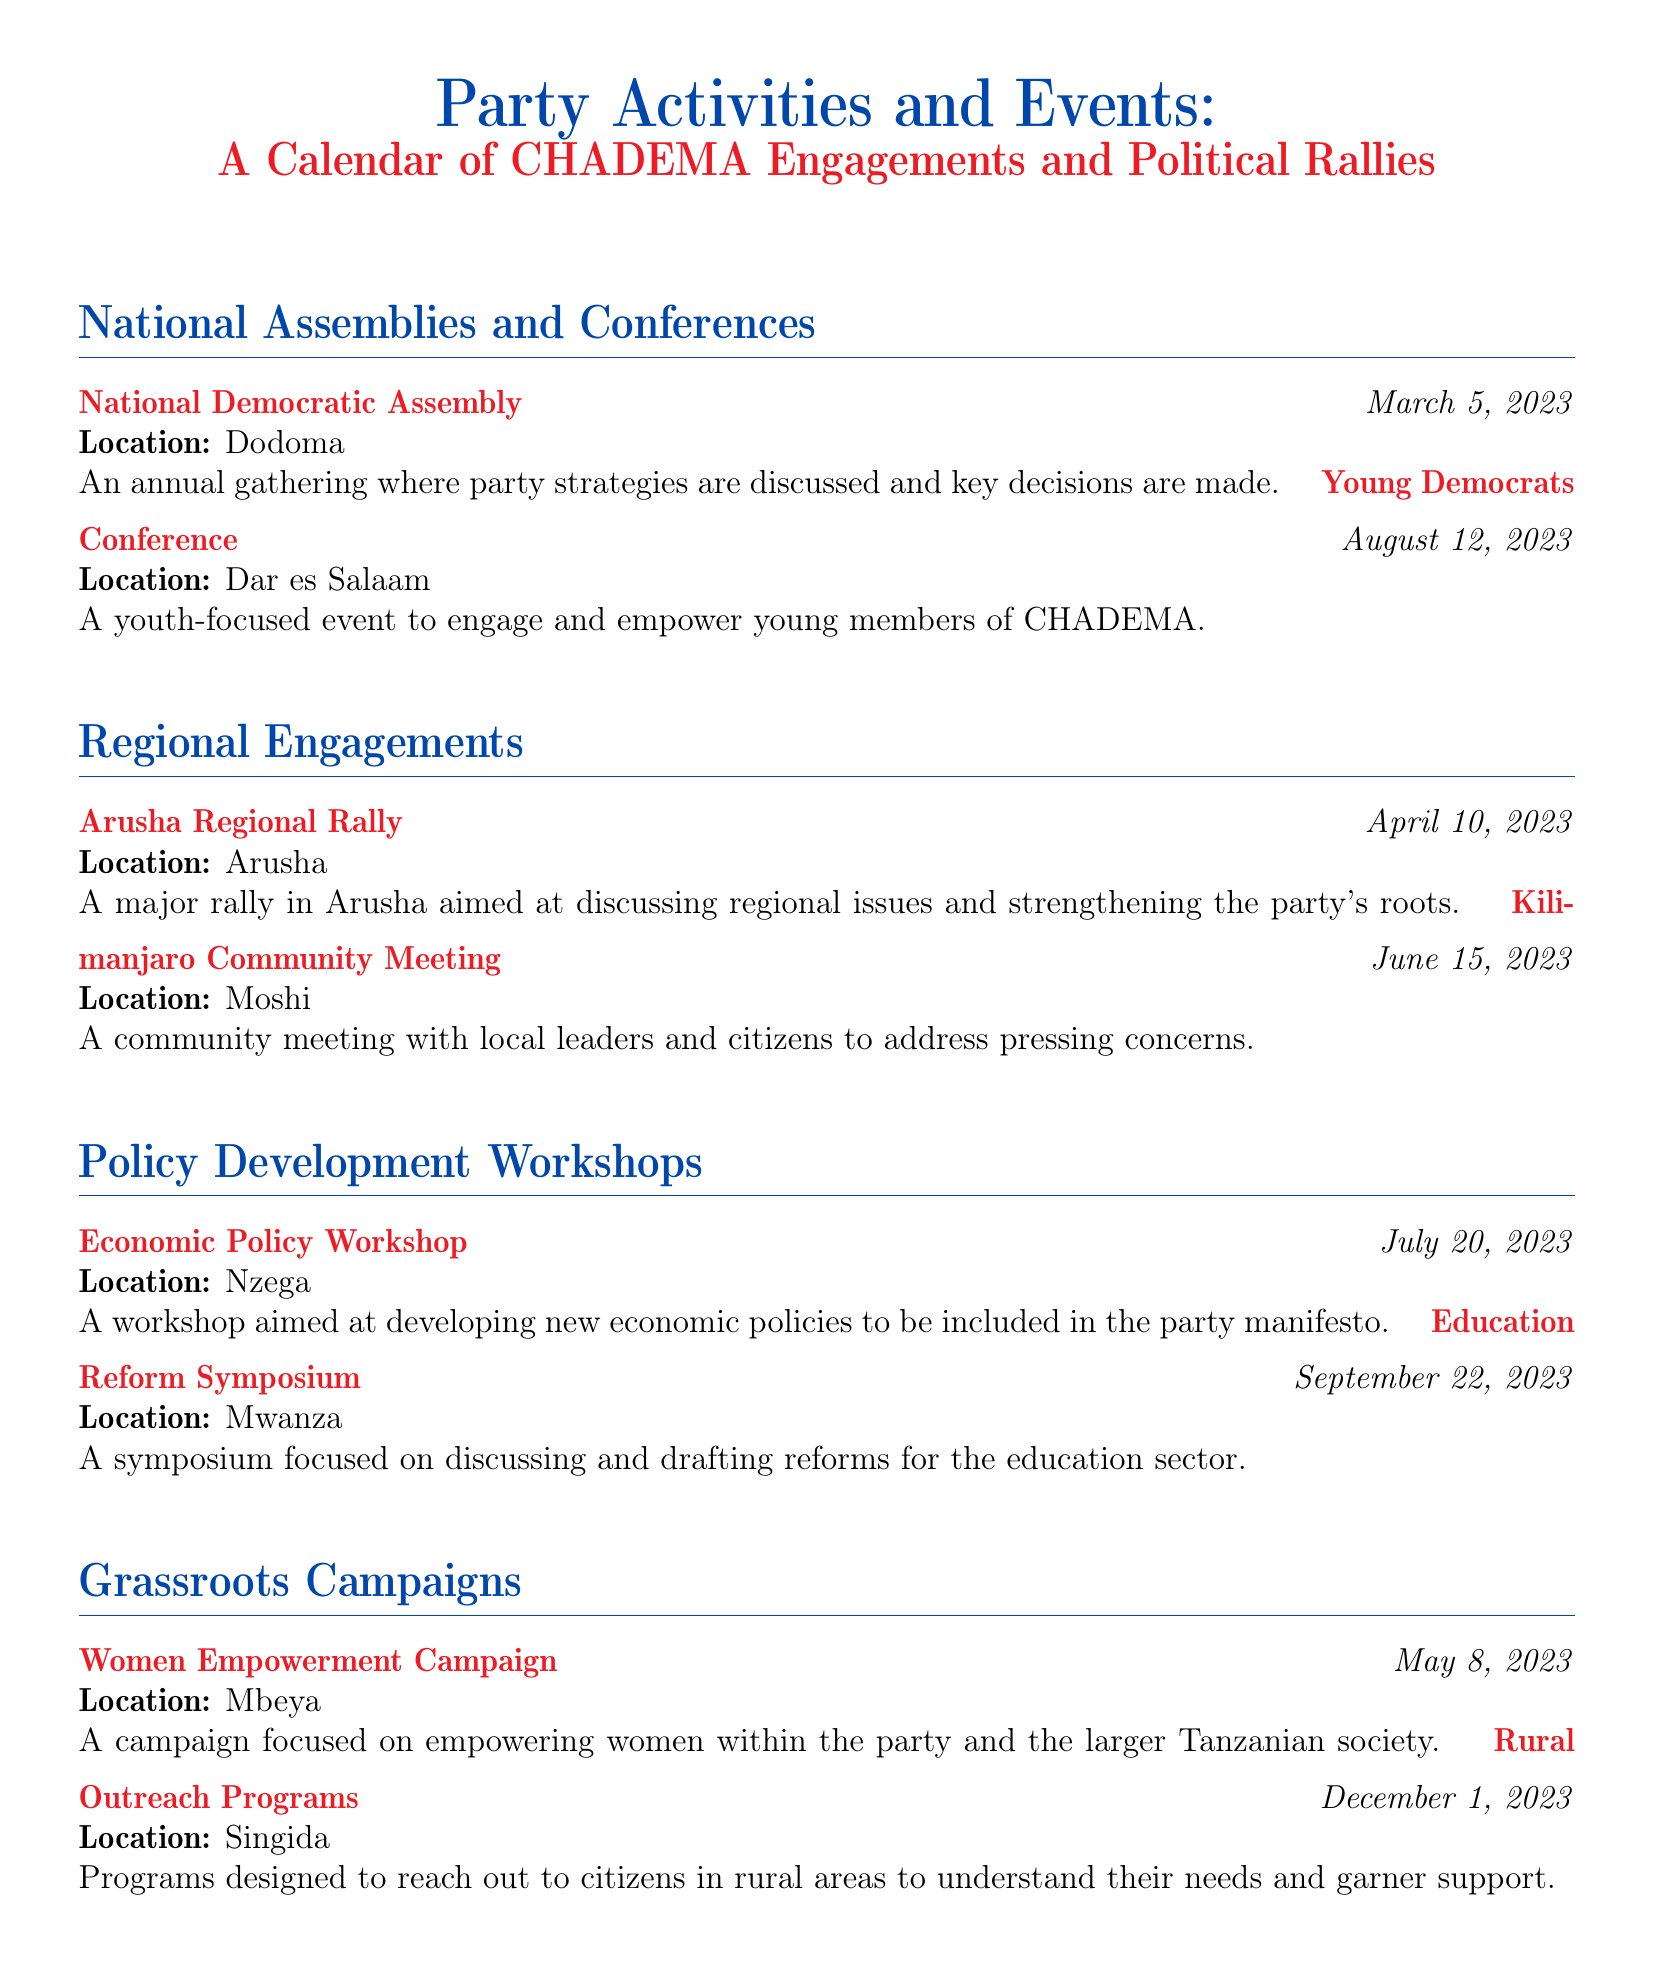What is the date of the National Democratic Assembly? The date of the National Democratic Assembly is specifically mentioned in the document.
Answer: March 5, 2023 Where is the Young Democrats Conference held? The location of the Young Democrats Conference is stated in the engagement details.
Answer: Dar es Salaam What is the focus of the Economic Policy Workshop? The document describes the purpose of the Economic Policy Workshop.
Answer: Developing new economic policies How many regional engagements are listed? By counting the engagements in the Regional Engagements section, we can find the total.
Answer: Two What is the purpose of the Women Empowerment Campaign? The document provides a clear statement on the aims of the Women Empowerment Campaign.
Answer: Empowering women Which meeting addresses education sector reforms? The specific meeting focused on education reforms is indicated in the document.
Answer: Education Reform Symposium What event occurs in December 2023? The document clearly lists the event scheduled for December 2023.
Answer: Rural Outreach Programs Which region has a rally on April 10, 2023? The document specifies the location of the rally on that date directly.
Answer: Arusha What is the subject of the symposium held on September 22, 2023? The subject of the symposium on that date is provided in the description.
Answer: Education sector reforms 